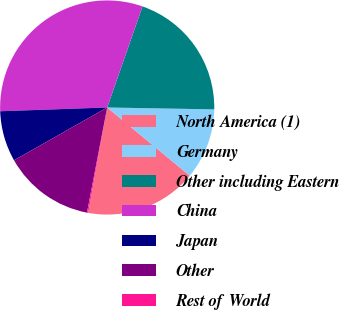<chart> <loc_0><loc_0><loc_500><loc_500><pie_chart><fcel>North America (1)<fcel>Germany<fcel>Other including Eastern<fcel>China<fcel>Japan<fcel>Other<fcel>Rest of World<nl><fcel>16.85%<fcel>10.71%<fcel>19.93%<fcel>30.91%<fcel>7.64%<fcel>13.78%<fcel>0.18%<nl></chart> 